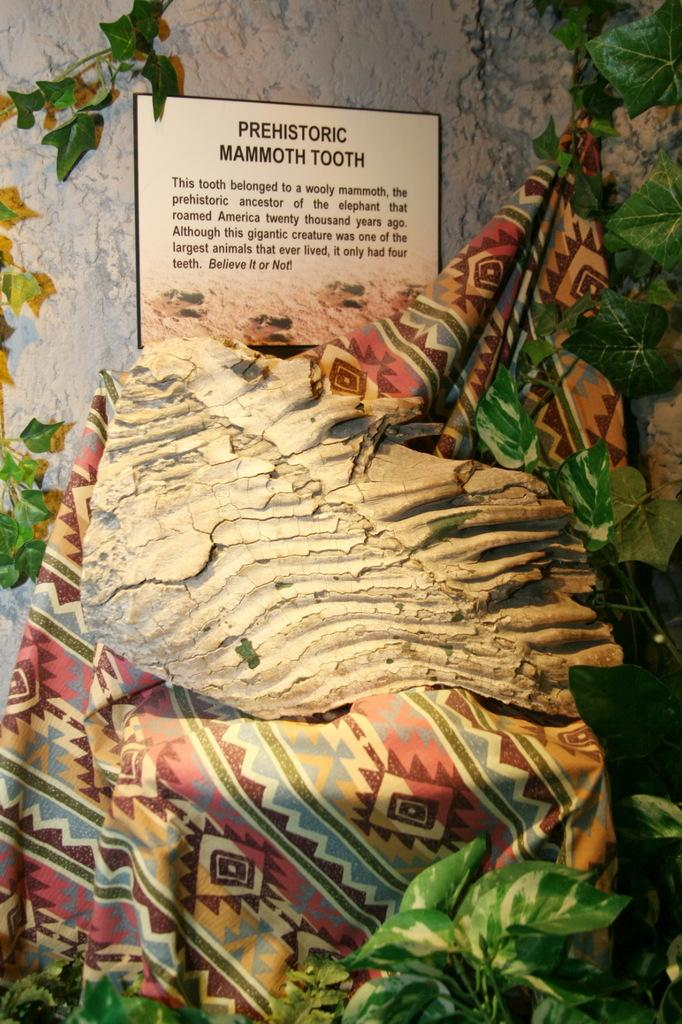<image>
Describe the image concisely. Prehistoric Mammoth Tooth that is shown in a museum. 